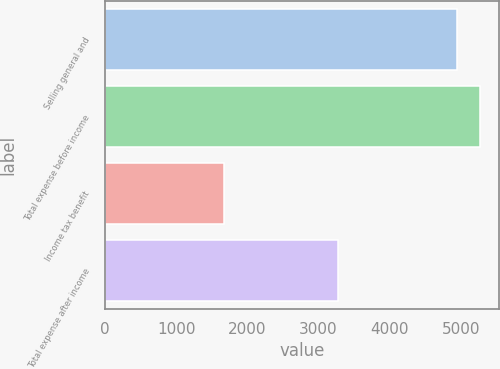Convert chart. <chart><loc_0><loc_0><loc_500><loc_500><bar_chart><fcel>Selling general and<fcel>Total expense before income<fcel>Income tax benefit<fcel>Total expense after income<nl><fcel>4946<fcel>5273.6<fcel>1670<fcel>3276<nl></chart> 